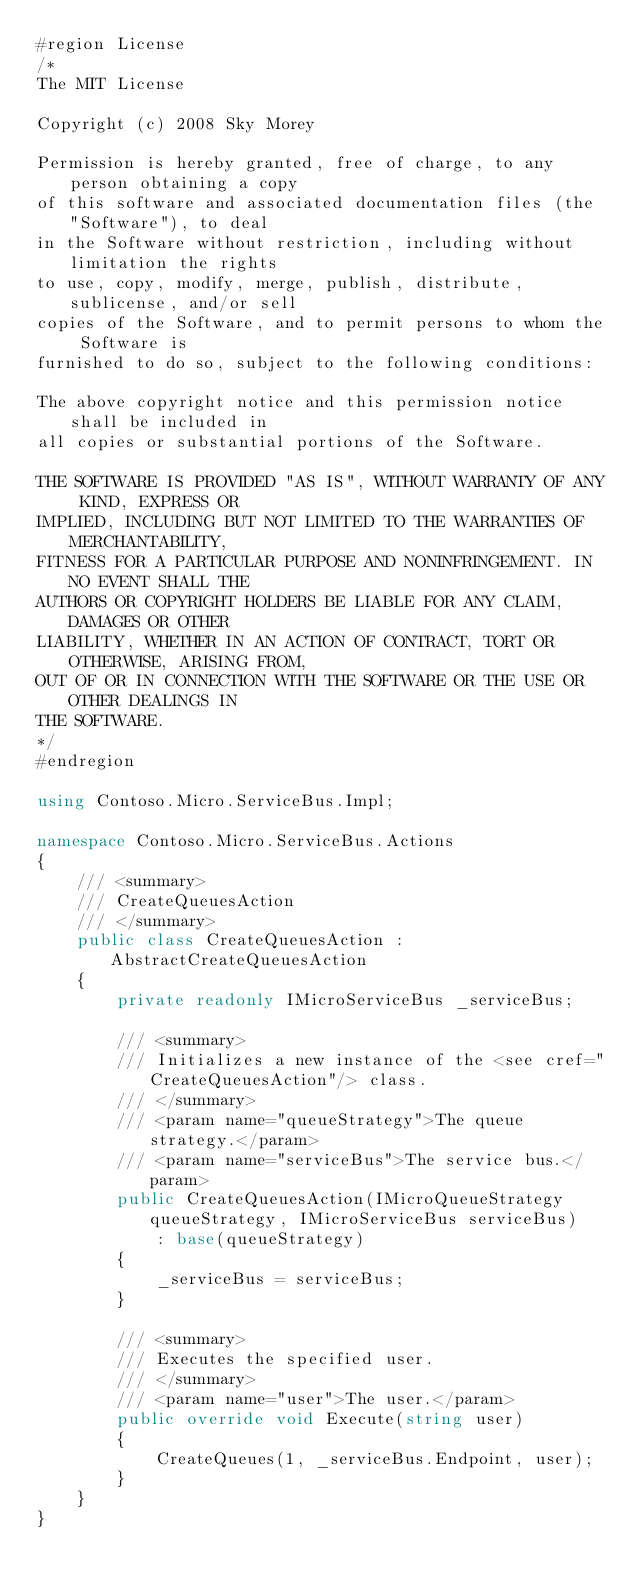Convert code to text. <code><loc_0><loc_0><loc_500><loc_500><_C#_>#region License
/*
The MIT License

Copyright (c) 2008 Sky Morey

Permission is hereby granted, free of charge, to any person obtaining a copy
of this software and associated documentation files (the "Software"), to deal
in the Software without restriction, including without limitation the rights
to use, copy, modify, merge, publish, distribute, sublicense, and/or sell
copies of the Software, and to permit persons to whom the Software is
furnished to do so, subject to the following conditions:

The above copyright notice and this permission notice shall be included in
all copies or substantial portions of the Software.

THE SOFTWARE IS PROVIDED "AS IS", WITHOUT WARRANTY OF ANY KIND, EXPRESS OR
IMPLIED, INCLUDING BUT NOT LIMITED TO THE WARRANTIES OF MERCHANTABILITY,
FITNESS FOR A PARTICULAR PURPOSE AND NONINFRINGEMENT. IN NO EVENT SHALL THE
AUTHORS OR COPYRIGHT HOLDERS BE LIABLE FOR ANY CLAIM, DAMAGES OR OTHER
LIABILITY, WHETHER IN AN ACTION OF CONTRACT, TORT OR OTHERWISE, ARISING FROM,
OUT OF OR IN CONNECTION WITH THE SOFTWARE OR THE USE OR OTHER DEALINGS IN
THE SOFTWARE.
*/
#endregion

using Contoso.Micro.ServiceBus.Impl;

namespace Contoso.Micro.ServiceBus.Actions
{
    /// <summary>
    /// CreateQueuesAction
    /// </summary>
    public class CreateQueuesAction : AbstractCreateQueuesAction
    {
        private readonly IMicroServiceBus _serviceBus;

        /// <summary>
        /// Initializes a new instance of the <see cref="CreateQueuesAction"/> class.
        /// </summary>
        /// <param name="queueStrategy">The queue strategy.</param>
        /// <param name="serviceBus">The service bus.</param>
        public CreateQueuesAction(IMicroQueueStrategy queueStrategy, IMicroServiceBus serviceBus)
            : base(queueStrategy)
        {
            _serviceBus = serviceBus;
        }

        /// <summary>
        /// Executes the specified user.
        /// </summary>
        /// <param name="user">The user.</param>
        public override void Execute(string user)
        {
            CreateQueues(1, _serviceBus.Endpoint, user);
        }
    }
}</code> 